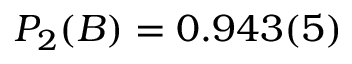<formula> <loc_0><loc_0><loc_500><loc_500>P _ { 2 } ( B ) = 0 . 9 4 3 ( 5 )</formula> 